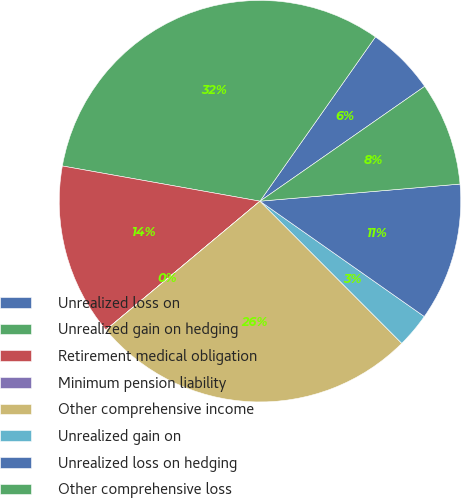Convert chart. <chart><loc_0><loc_0><loc_500><loc_500><pie_chart><fcel>Unrealized loss on<fcel>Unrealized gain on hedging<fcel>Retirement medical obligation<fcel>Minimum pension liability<fcel>Other comprehensive income<fcel>Unrealized gain on<fcel>Unrealized loss on hedging<fcel>Other comprehensive loss<nl><fcel>5.56%<fcel>31.94%<fcel>13.88%<fcel>0.01%<fcel>26.39%<fcel>2.78%<fcel>11.1%<fcel>8.33%<nl></chart> 